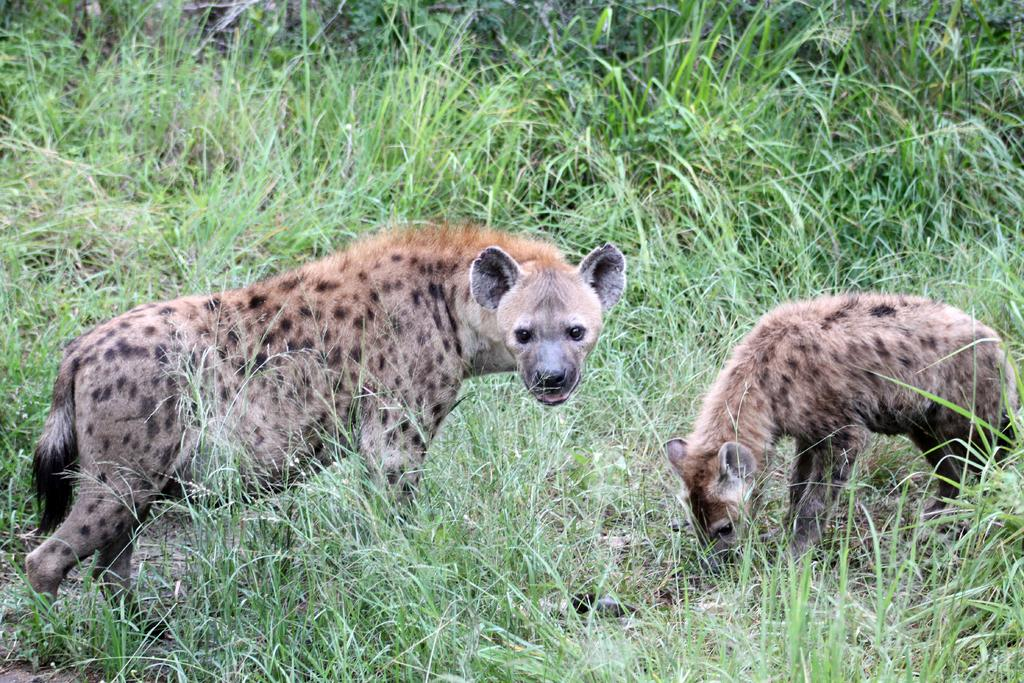What type of living organisms can be seen in the image? There are animals in the image. Where are the animals located? The animals are in the grass. What type of currency is visible in the image? There is no currency visible in the image; it features animals in the grass. What color is the paint used on the animals in the image? There is no paint applied to the animals in the image; they are depicted in their natural colors. 